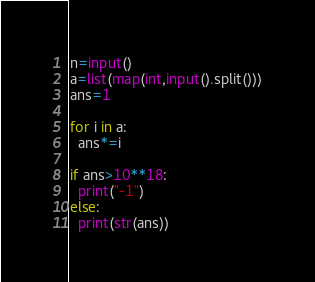Convert code to text. <code><loc_0><loc_0><loc_500><loc_500><_Python_>n=input()
a=list(map(int,input().split()))
ans=1

for i in a:
  ans*=i
  
if ans>10**18:
  print("-1")
else:
  print(str(ans))</code> 